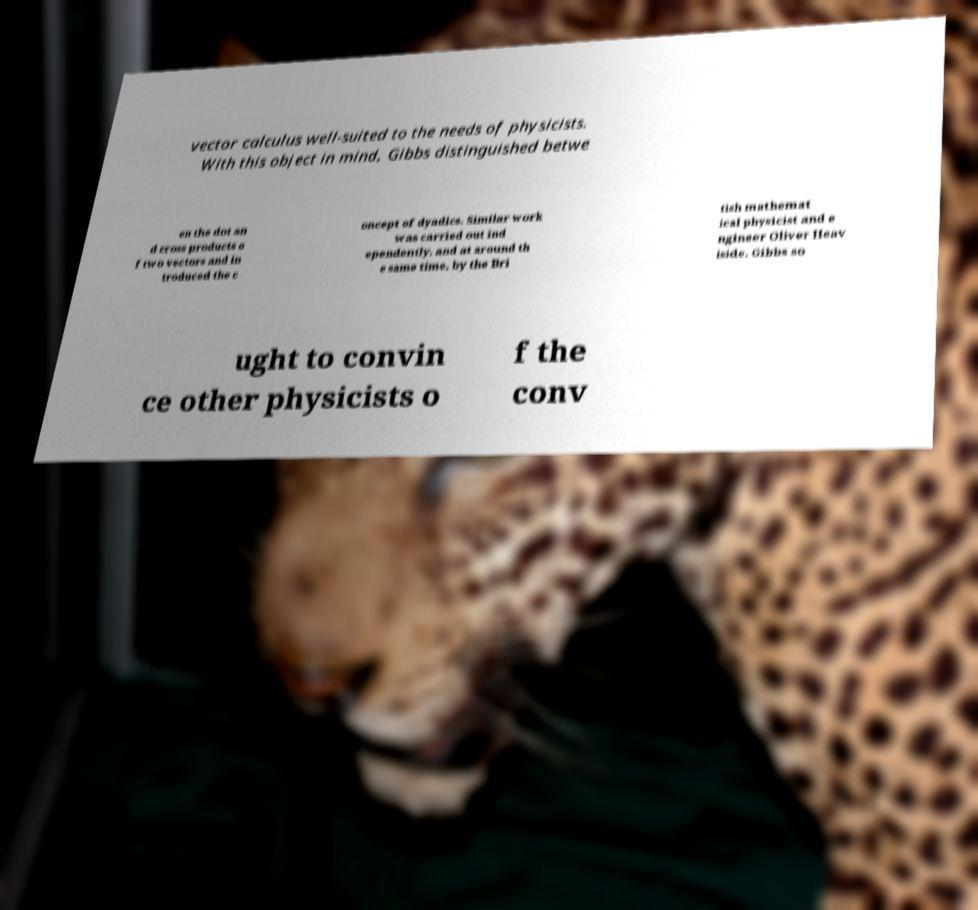Please identify and transcribe the text found in this image. vector calculus well-suited to the needs of physicists. With this object in mind, Gibbs distinguished betwe en the dot an d cross products o f two vectors and in troduced the c oncept of dyadics. Similar work was carried out ind ependently, and at around th e same time, by the Bri tish mathemat ical physicist and e ngineer Oliver Heav iside. Gibbs so ught to convin ce other physicists o f the conv 